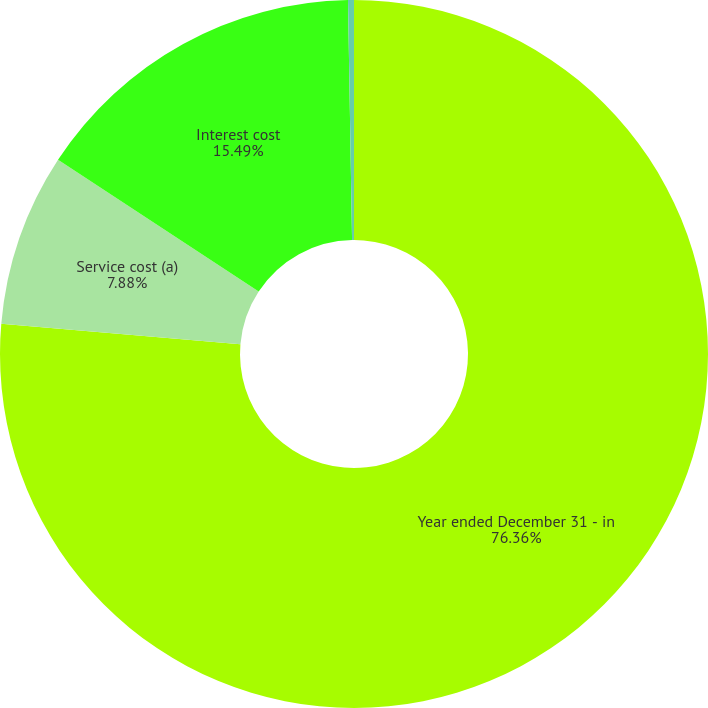Convert chart. <chart><loc_0><loc_0><loc_500><loc_500><pie_chart><fcel>Year ended December 31 - in<fcel>Service cost (a)<fcel>Interest cost<fcel>Amortization of prior service<nl><fcel>76.37%<fcel>7.88%<fcel>15.49%<fcel>0.27%<nl></chart> 